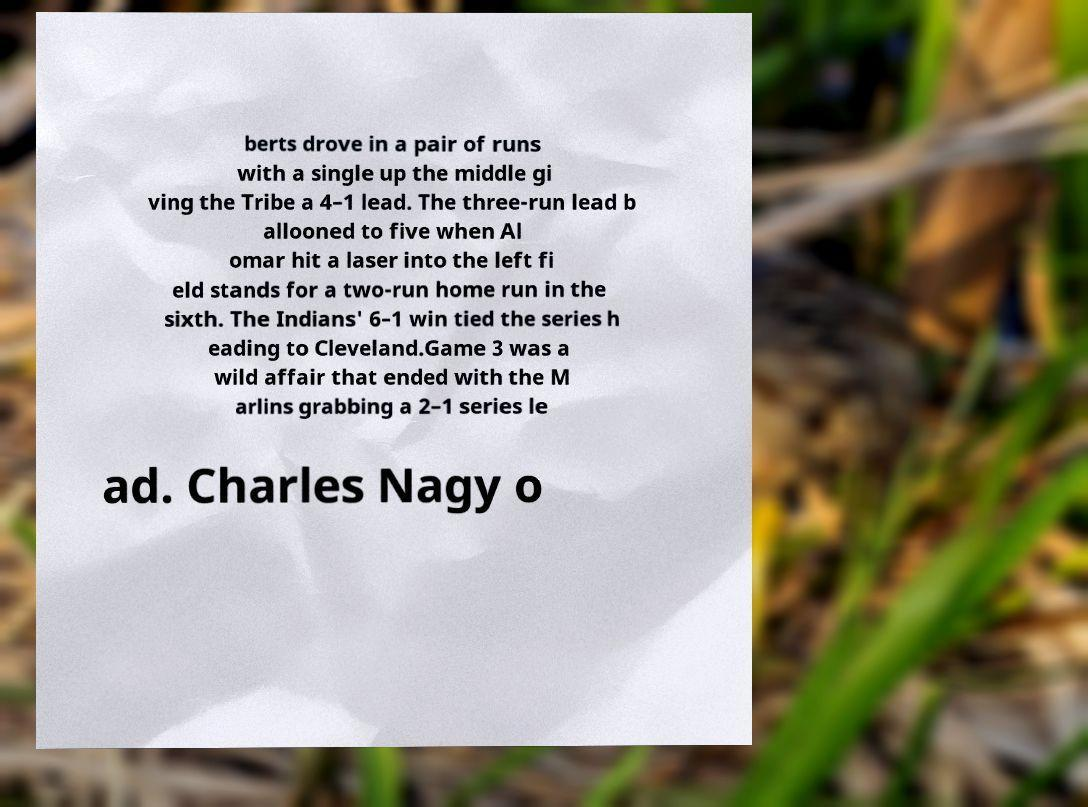What messages or text are displayed in this image? I need them in a readable, typed format. berts drove in a pair of runs with a single up the middle gi ving the Tribe a 4–1 lead. The three-run lead b allooned to five when Al omar hit a laser into the left fi eld stands for a two-run home run in the sixth. The Indians' 6–1 win tied the series h eading to Cleveland.Game 3 was a wild affair that ended with the M arlins grabbing a 2–1 series le ad. Charles Nagy o 